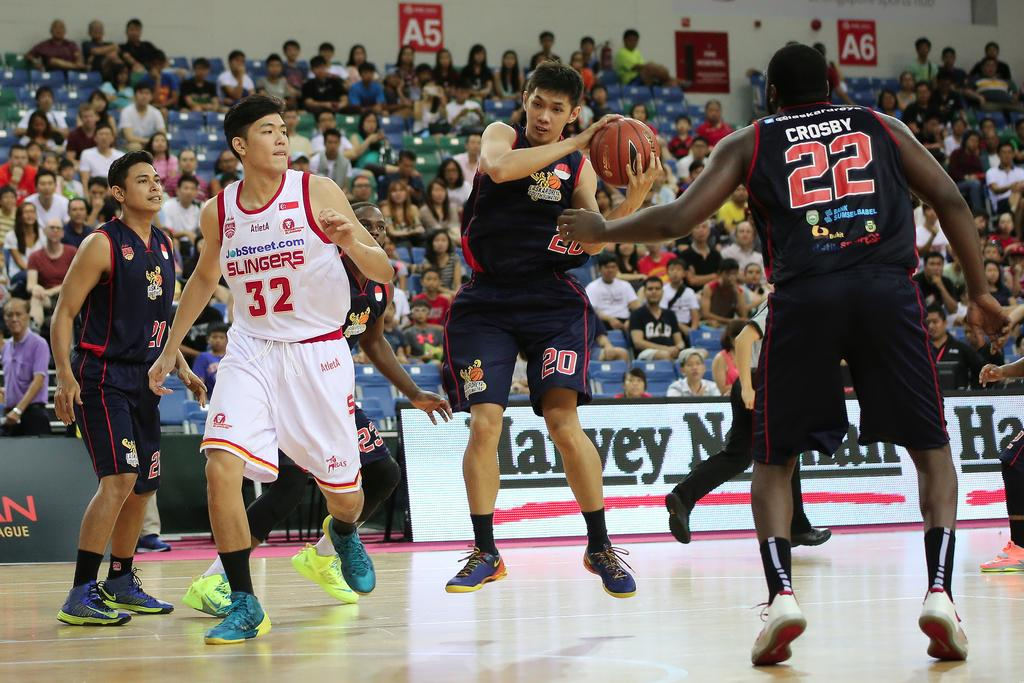<image>
Create a compact narrative representing the image presented. A man in a Slingers basketball uniform tries to keep up with the other players. 